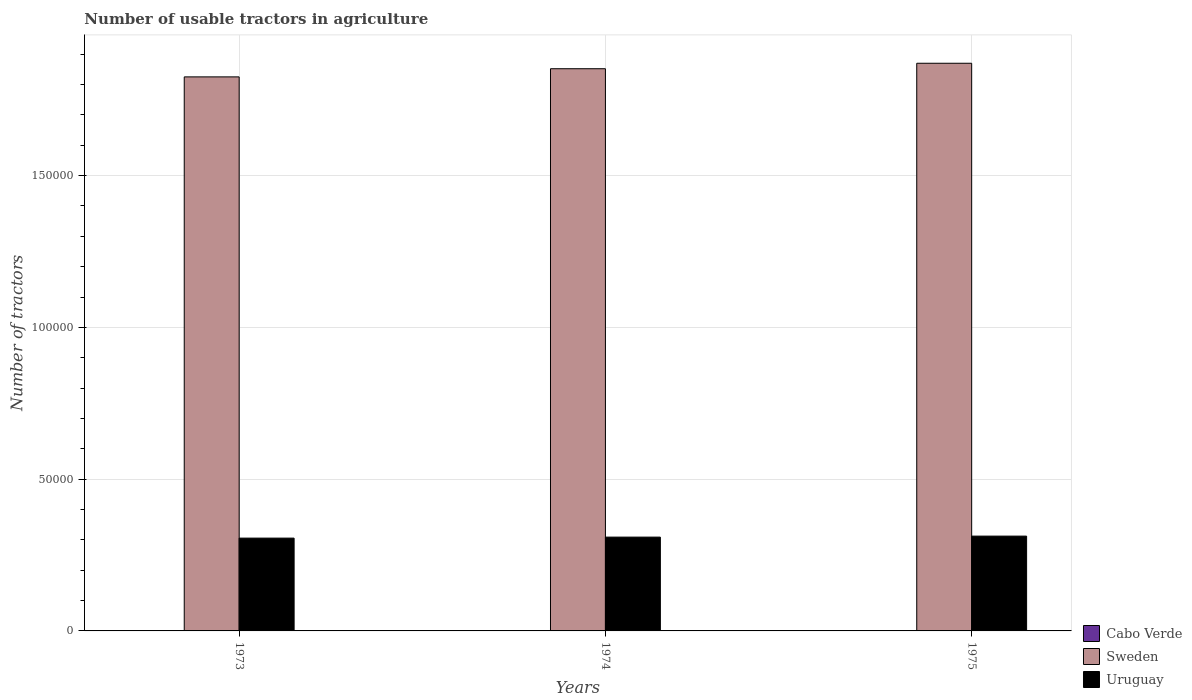Are the number of bars on each tick of the X-axis equal?
Offer a very short reply. Yes. How many bars are there on the 3rd tick from the right?
Provide a succinct answer. 3. In how many cases, is the number of bars for a given year not equal to the number of legend labels?
Offer a very short reply. 0. What is the number of usable tractors in agriculture in Sweden in 1975?
Make the answer very short. 1.87e+05. Across all years, what is the maximum number of usable tractors in agriculture in Sweden?
Give a very brief answer. 1.87e+05. Across all years, what is the minimum number of usable tractors in agriculture in Uruguay?
Your answer should be compact. 3.06e+04. In which year was the number of usable tractors in agriculture in Sweden maximum?
Ensure brevity in your answer.  1975. What is the total number of usable tractors in agriculture in Uruguay in the graph?
Offer a very short reply. 9.27e+04. What is the difference between the number of usable tractors in agriculture in Uruguay in 1973 and that in 1975?
Make the answer very short. -660. What is the difference between the number of usable tractors in agriculture in Uruguay in 1975 and the number of usable tractors in agriculture in Sweden in 1974?
Provide a short and direct response. -1.54e+05. What is the average number of usable tractors in agriculture in Uruguay per year?
Give a very brief answer. 3.09e+04. In the year 1973, what is the difference between the number of usable tractors in agriculture in Sweden and number of usable tractors in agriculture in Uruguay?
Provide a short and direct response. 1.52e+05. What is the ratio of the number of usable tractors in agriculture in Cabo Verde in 1973 to that in 1975?
Make the answer very short. 0.78. Is the number of usable tractors in agriculture in Uruguay in 1973 less than that in 1975?
Make the answer very short. Yes. Is the difference between the number of usable tractors in agriculture in Sweden in 1974 and 1975 greater than the difference between the number of usable tractors in agriculture in Uruguay in 1974 and 1975?
Your answer should be very brief. No. What is the difference between the highest and the second highest number of usable tractors in agriculture in Cabo Verde?
Your answer should be compact. 2. What is the difference between the highest and the lowest number of usable tractors in agriculture in Sweden?
Provide a short and direct response. 4486. In how many years, is the number of usable tractors in agriculture in Uruguay greater than the average number of usable tractors in agriculture in Uruguay taken over all years?
Ensure brevity in your answer.  1. What does the 1st bar from the left in 1973 represents?
Your answer should be very brief. Cabo Verde. What does the 1st bar from the right in 1975 represents?
Ensure brevity in your answer.  Uruguay. Is it the case that in every year, the sum of the number of usable tractors in agriculture in Cabo Verde and number of usable tractors in agriculture in Uruguay is greater than the number of usable tractors in agriculture in Sweden?
Keep it short and to the point. No. Are all the bars in the graph horizontal?
Keep it short and to the point. No. How many years are there in the graph?
Offer a very short reply. 3. Does the graph contain grids?
Give a very brief answer. Yes. What is the title of the graph?
Ensure brevity in your answer.  Number of usable tractors in agriculture. Does "Tajikistan" appear as one of the legend labels in the graph?
Offer a very short reply. No. What is the label or title of the Y-axis?
Your answer should be compact. Number of tractors. What is the Number of tractors in Cabo Verde in 1973?
Provide a short and direct response. 7. What is the Number of tractors in Sweden in 1973?
Provide a succinct answer. 1.83e+05. What is the Number of tractors of Uruguay in 1973?
Your answer should be very brief. 3.06e+04. What is the Number of tractors of Sweden in 1974?
Your response must be concise. 1.85e+05. What is the Number of tractors of Uruguay in 1974?
Your answer should be compact. 3.09e+04. What is the Number of tractors of Cabo Verde in 1975?
Ensure brevity in your answer.  9. What is the Number of tractors in Sweden in 1975?
Ensure brevity in your answer.  1.87e+05. What is the Number of tractors of Uruguay in 1975?
Your answer should be compact. 3.12e+04. Across all years, what is the maximum Number of tractors of Cabo Verde?
Provide a short and direct response. 9. Across all years, what is the maximum Number of tractors of Sweden?
Keep it short and to the point. 1.87e+05. Across all years, what is the maximum Number of tractors in Uruguay?
Your answer should be very brief. 3.12e+04. Across all years, what is the minimum Number of tractors of Sweden?
Make the answer very short. 1.83e+05. Across all years, what is the minimum Number of tractors of Uruguay?
Make the answer very short. 3.06e+04. What is the total Number of tractors of Sweden in the graph?
Provide a succinct answer. 5.55e+05. What is the total Number of tractors of Uruguay in the graph?
Your response must be concise. 9.27e+04. What is the difference between the Number of tractors of Cabo Verde in 1973 and that in 1974?
Your answer should be compact. 0. What is the difference between the Number of tractors of Sweden in 1973 and that in 1974?
Keep it short and to the point. -2686. What is the difference between the Number of tractors in Uruguay in 1973 and that in 1974?
Give a very brief answer. -330. What is the difference between the Number of tractors of Sweden in 1973 and that in 1975?
Offer a very short reply. -4486. What is the difference between the Number of tractors in Uruguay in 1973 and that in 1975?
Keep it short and to the point. -660. What is the difference between the Number of tractors of Sweden in 1974 and that in 1975?
Make the answer very short. -1800. What is the difference between the Number of tractors of Uruguay in 1974 and that in 1975?
Ensure brevity in your answer.  -330. What is the difference between the Number of tractors of Cabo Verde in 1973 and the Number of tractors of Sweden in 1974?
Provide a succinct answer. -1.85e+05. What is the difference between the Number of tractors in Cabo Verde in 1973 and the Number of tractors in Uruguay in 1974?
Offer a terse response. -3.09e+04. What is the difference between the Number of tractors of Sweden in 1973 and the Number of tractors of Uruguay in 1974?
Keep it short and to the point. 1.52e+05. What is the difference between the Number of tractors of Cabo Verde in 1973 and the Number of tractors of Sweden in 1975?
Provide a succinct answer. -1.87e+05. What is the difference between the Number of tractors in Cabo Verde in 1973 and the Number of tractors in Uruguay in 1975?
Provide a succinct answer. -3.12e+04. What is the difference between the Number of tractors of Sweden in 1973 and the Number of tractors of Uruguay in 1975?
Your answer should be compact. 1.51e+05. What is the difference between the Number of tractors of Cabo Verde in 1974 and the Number of tractors of Sweden in 1975?
Give a very brief answer. -1.87e+05. What is the difference between the Number of tractors of Cabo Verde in 1974 and the Number of tractors of Uruguay in 1975?
Offer a terse response. -3.12e+04. What is the difference between the Number of tractors of Sweden in 1974 and the Number of tractors of Uruguay in 1975?
Give a very brief answer. 1.54e+05. What is the average Number of tractors in Cabo Verde per year?
Provide a succinct answer. 7.67. What is the average Number of tractors in Sweden per year?
Make the answer very short. 1.85e+05. What is the average Number of tractors of Uruguay per year?
Keep it short and to the point. 3.09e+04. In the year 1973, what is the difference between the Number of tractors of Cabo Verde and Number of tractors of Sweden?
Provide a short and direct response. -1.83e+05. In the year 1973, what is the difference between the Number of tractors of Cabo Verde and Number of tractors of Uruguay?
Offer a very short reply. -3.06e+04. In the year 1973, what is the difference between the Number of tractors in Sweden and Number of tractors in Uruguay?
Your response must be concise. 1.52e+05. In the year 1974, what is the difference between the Number of tractors of Cabo Verde and Number of tractors of Sweden?
Keep it short and to the point. -1.85e+05. In the year 1974, what is the difference between the Number of tractors of Cabo Verde and Number of tractors of Uruguay?
Provide a short and direct response. -3.09e+04. In the year 1974, what is the difference between the Number of tractors of Sweden and Number of tractors of Uruguay?
Make the answer very short. 1.54e+05. In the year 1975, what is the difference between the Number of tractors of Cabo Verde and Number of tractors of Sweden?
Offer a terse response. -1.87e+05. In the year 1975, what is the difference between the Number of tractors in Cabo Verde and Number of tractors in Uruguay?
Your response must be concise. -3.12e+04. In the year 1975, what is the difference between the Number of tractors in Sweden and Number of tractors in Uruguay?
Your answer should be very brief. 1.56e+05. What is the ratio of the Number of tractors of Sweden in 1973 to that in 1974?
Offer a very short reply. 0.99. What is the ratio of the Number of tractors in Uruguay in 1973 to that in 1974?
Make the answer very short. 0.99. What is the ratio of the Number of tractors of Uruguay in 1973 to that in 1975?
Offer a very short reply. 0.98. What is the ratio of the Number of tractors in Cabo Verde in 1974 to that in 1975?
Give a very brief answer. 0.78. What is the difference between the highest and the second highest Number of tractors in Sweden?
Your answer should be very brief. 1800. What is the difference between the highest and the second highest Number of tractors in Uruguay?
Give a very brief answer. 330. What is the difference between the highest and the lowest Number of tractors of Cabo Verde?
Give a very brief answer. 2. What is the difference between the highest and the lowest Number of tractors in Sweden?
Make the answer very short. 4486. What is the difference between the highest and the lowest Number of tractors in Uruguay?
Provide a short and direct response. 660. 